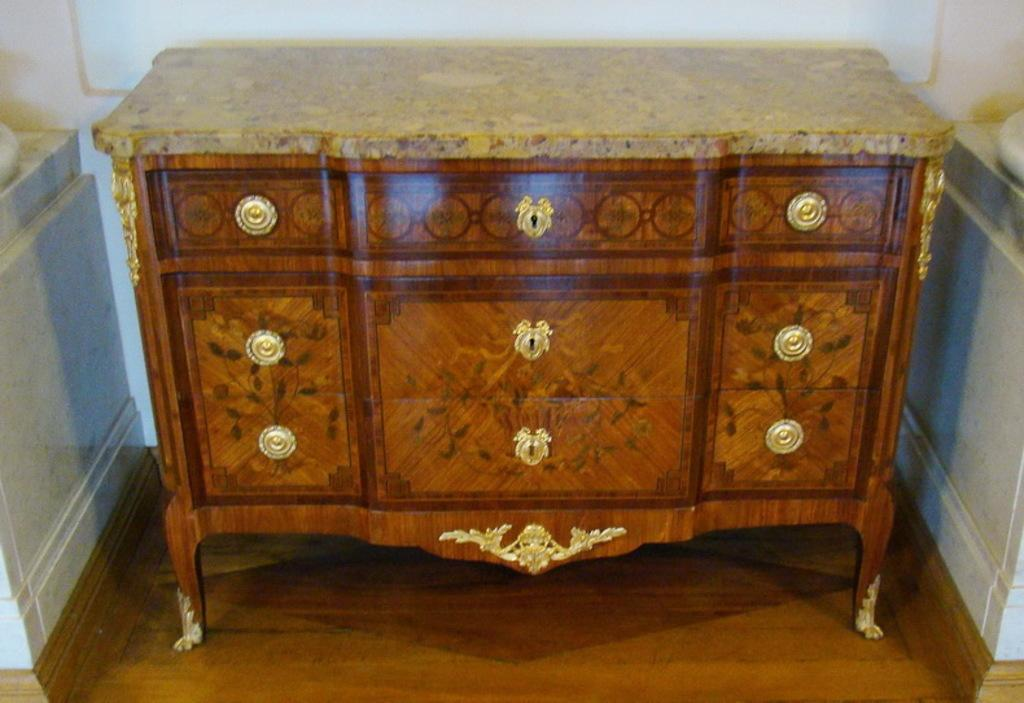What color is the wall in the image? The wall in the image is white. What color is the table in the image? The table in the image is brown. What type of battle is taking place in the image? There is no battle present in the image; it only features a white wall and a brown table. How many times does the stem rotate in the image? There is no stem present in the image, so it cannot be determined how many times it might rotate. 